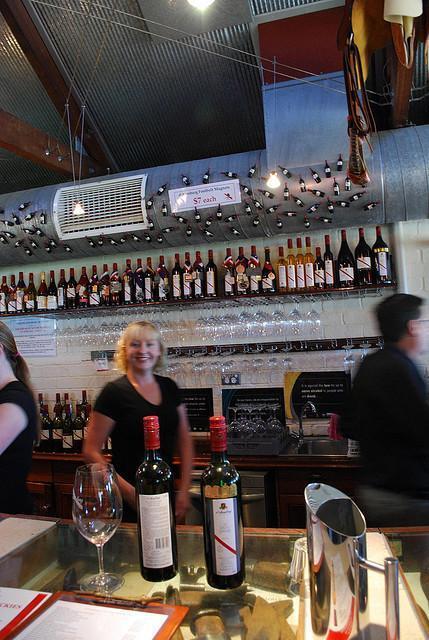How many bottles are pictured?
Give a very brief answer. 2. How many bottles can you see?
Give a very brief answer. 3. How many wine glasses are in the picture?
Give a very brief answer. 2. How many people are visible?
Give a very brief answer. 3. How many trains are shown?
Give a very brief answer. 0. 